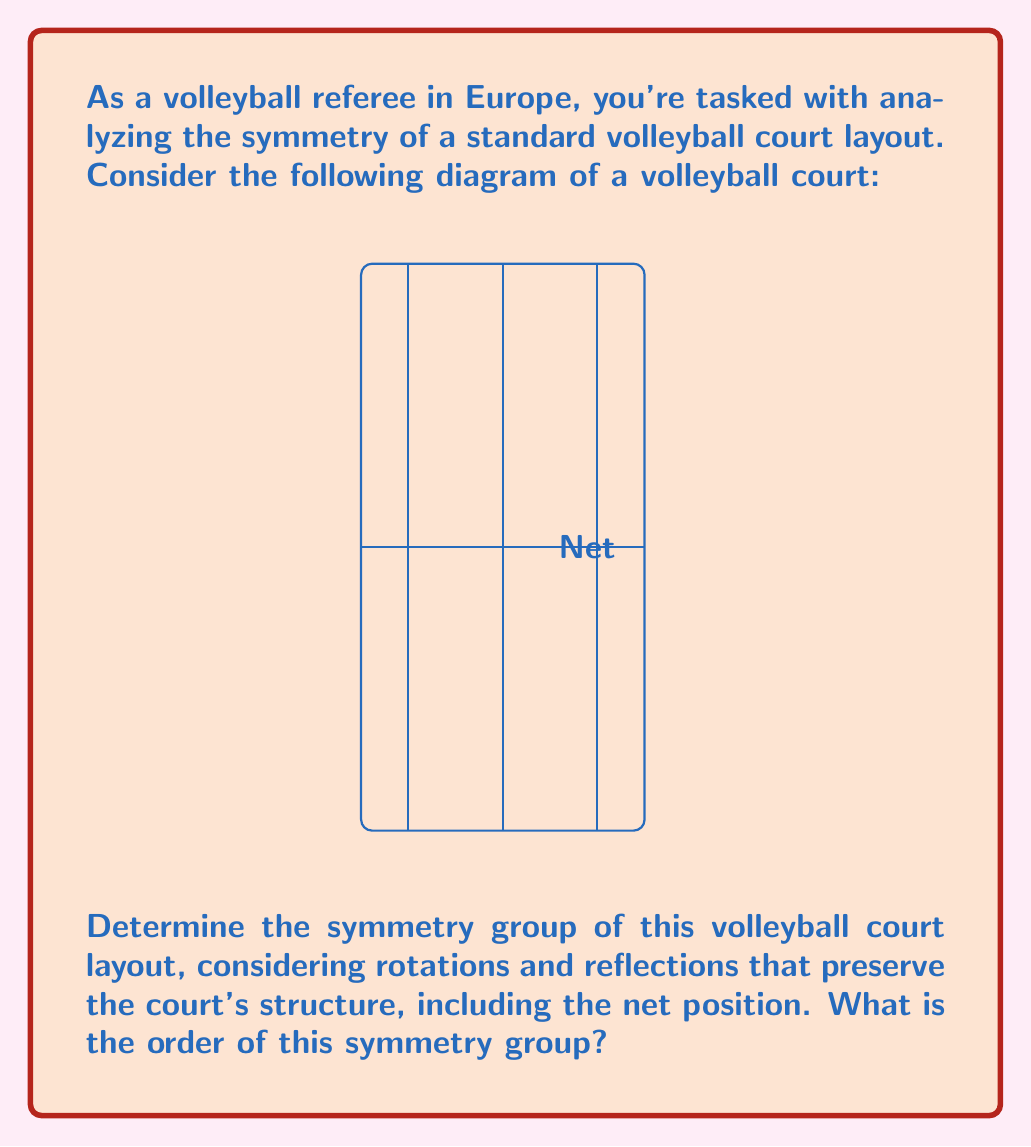What is the answer to this math problem? Let's analyze the symmetries of the volleyball court step-by-step:

1) Rotational symmetries:
   - The court has 180° rotational symmetry (2-fold rotation) around its center.
   - There are no other rotational symmetries.

2) Reflection symmetries:
   - Reflection across the net (vertical line through the center).
   - Reflection across the center line (horizontal line through the center).

3) Identity transformation (leaving the court unchanged).

To determine the symmetry group, we list all possible symmetry operations:
   e: Identity
   r: 180° rotation
   h: Horizontal reflection
   v: Vertical reflection

We can verify that these form a group:
   - The set is closed under composition.
   - The identity element e exists.
   - Each element has an inverse (in fact, each is its own inverse).
   - Composition is associative.

This group is isomorphic to the Klein four-group, $$V_4 = C_2 \times C_2$$.

The order of a group is the number of elements it contains. In this case, we have 4 elements: $e, r, h, v$.

Therefore, the symmetry group of the volleyball court is the Klein four-group, and its order is 4.
Answer: Klein four-group $V_4$; order 4 